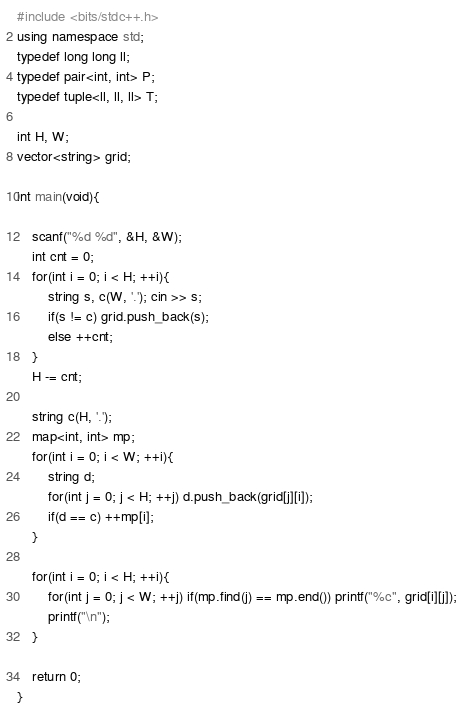Convert code to text. <code><loc_0><loc_0><loc_500><loc_500><_C++_>#include <bits/stdc++.h>
using namespace std;
typedef long long ll;
typedef pair<int, int> P;
typedef tuple<ll, ll, ll> T;

int H, W;
vector<string> grid;

int main(void){
    
    scanf("%d %d", &H, &W);
    int cnt = 0;
    for(int i = 0; i < H; ++i){
        string s, c(W, '.'); cin >> s;
        if(s != c) grid.push_back(s);
        else ++cnt;
    }
    H -= cnt;
    
    string c(H, '.');
    map<int, int> mp;
    for(int i = 0; i < W; ++i){
        string d;
        for(int j = 0; j < H; ++j) d.push_back(grid[j][i]);
        if(d == c) ++mp[i];
    }
    
    for(int i = 0; i < H; ++i){
        for(int j = 0; j < W; ++j) if(mp.find(j) == mp.end()) printf("%c", grid[i][j]);
        printf("\n");
    }
    
    return 0;
}</code> 